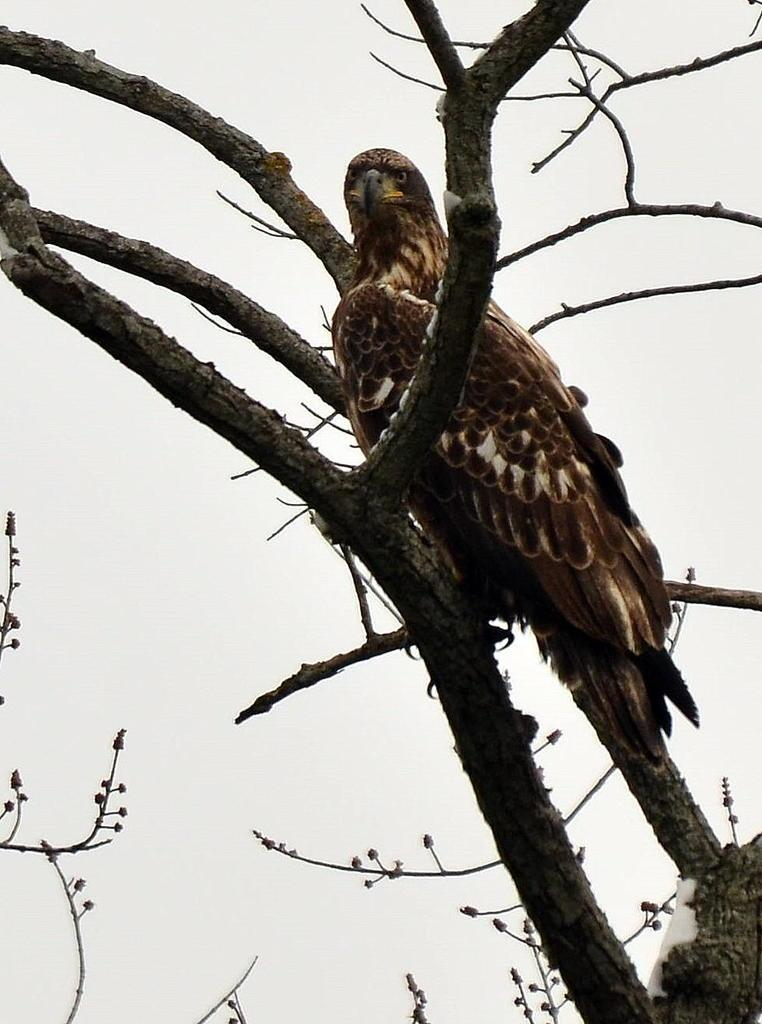What type of animal can be seen in the image? There is a bird in the image. Where is the bird located in the image? The bird is sitting on a tree. What is the color of the bird? The bird is in brown color. What is the color of the background in the image? The background of the image is white in color. What type of music can be heard coming from the tent in the image? There is no tent present in the image, so it's not possible to determine what, if any, music might be heard. 